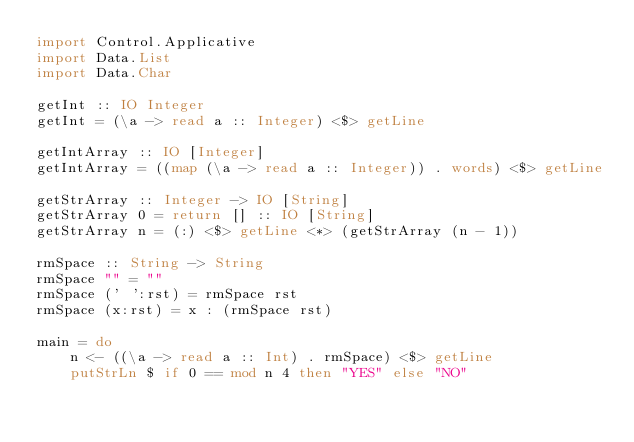Convert code to text. <code><loc_0><loc_0><loc_500><loc_500><_Haskell_>import Control.Applicative
import Data.List
import Data.Char

getInt :: IO Integer
getInt = (\a -> read a :: Integer) <$> getLine

getIntArray :: IO [Integer]
getIntArray = ((map (\a -> read a :: Integer)) . words) <$> getLine

getStrArray :: Integer -> IO [String]
getStrArray 0 = return [] :: IO [String]
getStrArray n = (:) <$> getLine <*> (getStrArray (n - 1))

rmSpace :: String -> String
rmSpace "" = ""
rmSpace (' ':rst) = rmSpace rst
rmSpace (x:rst) = x : (rmSpace rst)

main = do
    n <- ((\a -> read a :: Int) . rmSpace) <$> getLine
    putStrLn $ if 0 == mod n 4 then "YES" else "NO"
</code> 